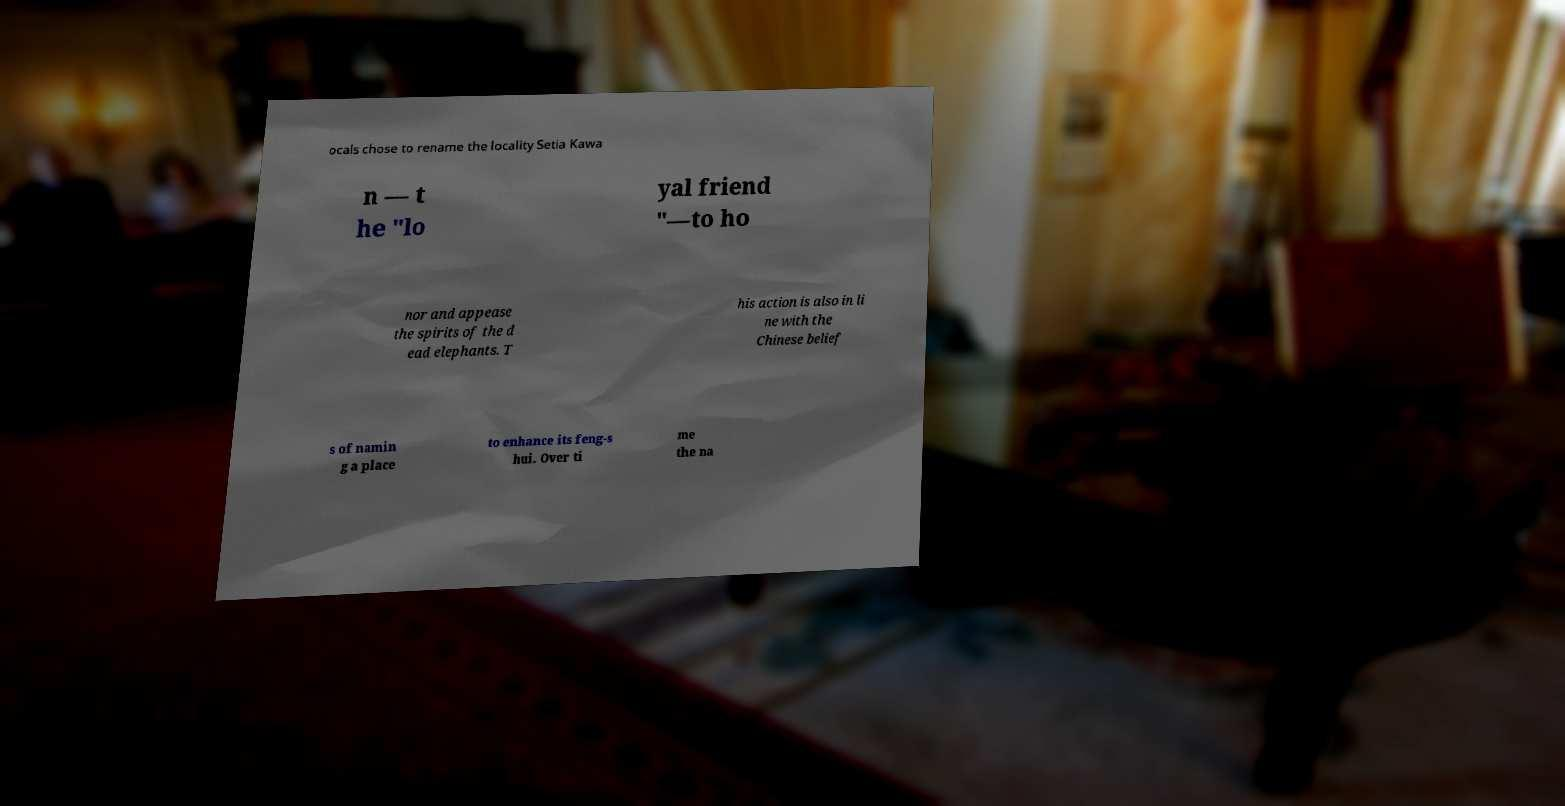Can you read and provide the text displayed in the image?This photo seems to have some interesting text. Can you extract and type it out for me? ocals chose to rename the locality Setia Kawa n — t he "lo yal friend "—to ho nor and appease the spirits of the d ead elephants. T his action is also in li ne with the Chinese belief s of namin g a place to enhance its feng-s hui. Over ti me the na 